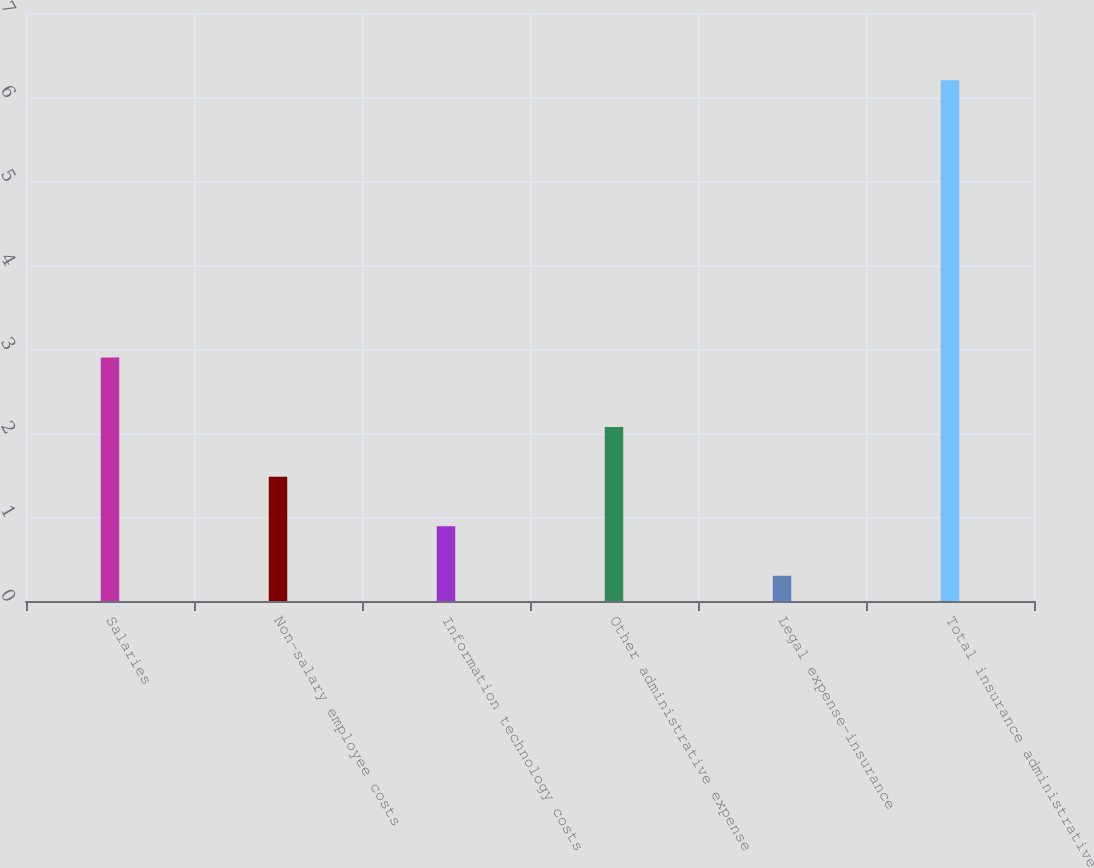<chart> <loc_0><loc_0><loc_500><loc_500><bar_chart><fcel>Salaries<fcel>Non-salary employee costs<fcel>Information technology costs<fcel>Other administrative expense<fcel>Legal expense-insurance<fcel>Total insurance administrative<nl><fcel>2.9<fcel>1.48<fcel>0.89<fcel>2.07<fcel>0.3<fcel>6.2<nl></chart> 